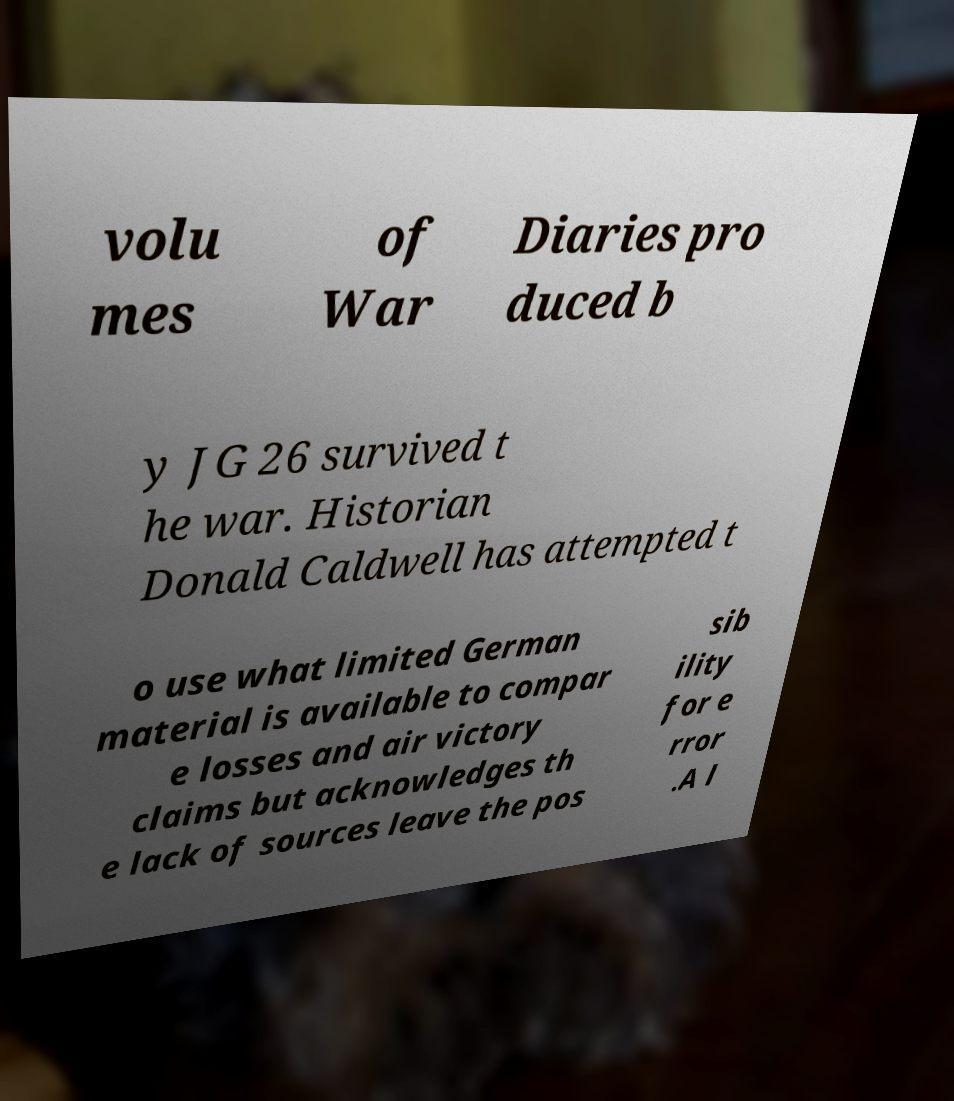Please identify and transcribe the text found in this image. volu mes of War Diaries pro duced b y JG 26 survived t he war. Historian Donald Caldwell has attempted t o use what limited German material is available to compar e losses and air victory claims but acknowledges th e lack of sources leave the pos sib ility for e rror .A l 